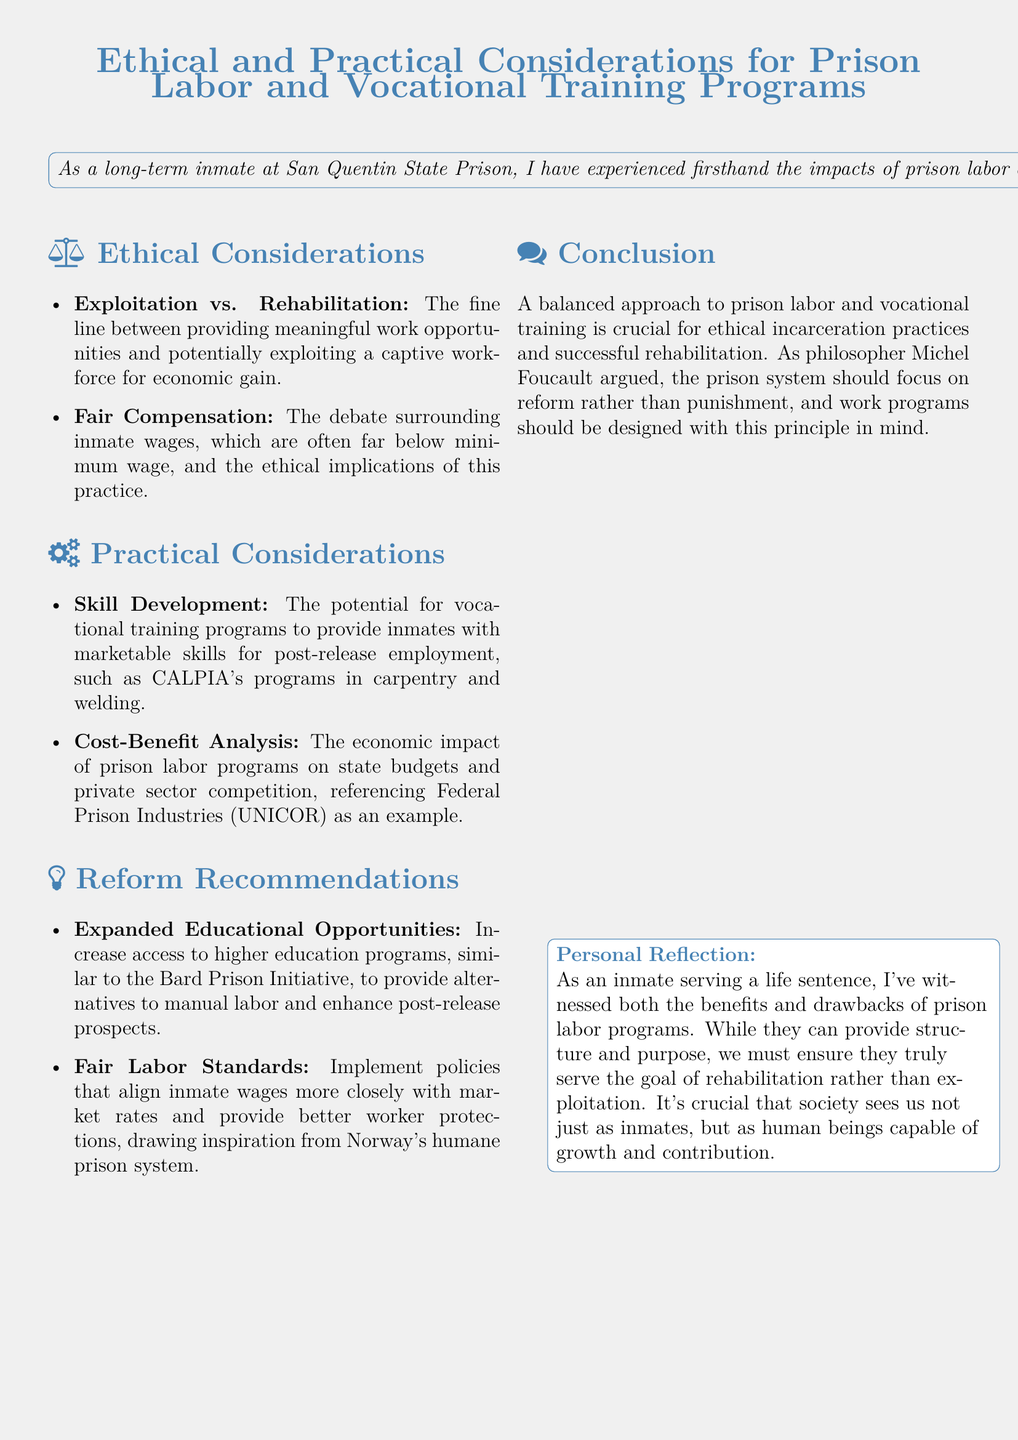What is the primary purpose of the policy document? The document aims to examine the ethical implications and practical considerations of prison labor and vocational training programs.
Answer: To examine ethical implications and practical considerations What are the two main ethical considerations listed? The ethical considerations include "Exploitation vs. Rehabilitation" and "Fair Compensation."
Answer: Exploitation vs. Rehabilitation, Fair Compensation Which organization is an example of a prison labor program mentioned? The document references Federal Prison Industries (UNICOR) as an example of a prison labor program.
Answer: Federal Prison Industries (UNICOR) What is one recommendation for reform mentioned in the document? The document suggests increasing access to higher education programs as a reform recommendation.
Answer: Expanded Educational Opportunities According to the document, who argued that the prison system should focus on reform? The conclusion states that Michel Foucault argued for reform in the prison system.
Answer: Michel Foucault 